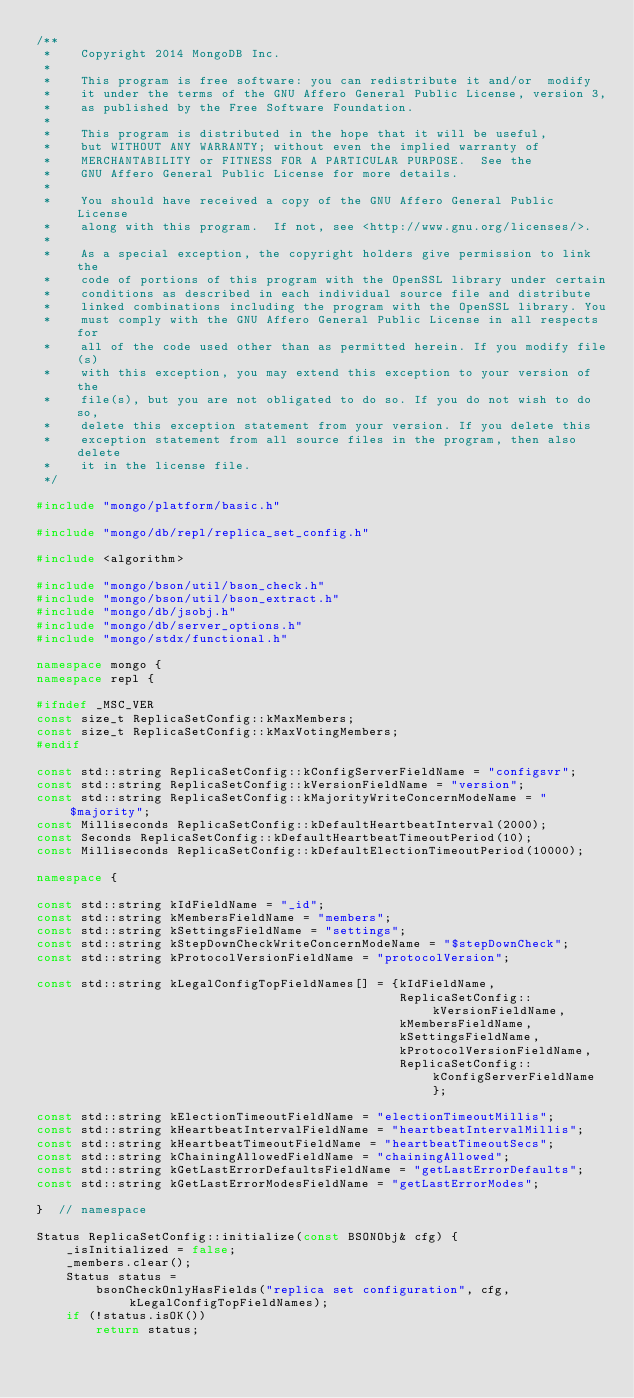<code> <loc_0><loc_0><loc_500><loc_500><_C++_>/**
 *    Copyright 2014 MongoDB Inc.
 *
 *    This program is free software: you can redistribute it and/or  modify
 *    it under the terms of the GNU Affero General Public License, version 3,
 *    as published by the Free Software Foundation.
 *
 *    This program is distributed in the hope that it will be useful,
 *    but WITHOUT ANY WARRANTY; without even the implied warranty of
 *    MERCHANTABILITY or FITNESS FOR A PARTICULAR PURPOSE.  See the
 *    GNU Affero General Public License for more details.
 *
 *    You should have received a copy of the GNU Affero General Public License
 *    along with this program.  If not, see <http://www.gnu.org/licenses/>.
 *
 *    As a special exception, the copyright holders give permission to link the
 *    code of portions of this program with the OpenSSL library under certain
 *    conditions as described in each individual source file and distribute
 *    linked combinations including the program with the OpenSSL library. You
 *    must comply with the GNU Affero General Public License in all respects for
 *    all of the code used other than as permitted herein. If you modify file(s)
 *    with this exception, you may extend this exception to your version of the
 *    file(s), but you are not obligated to do so. If you do not wish to do so,
 *    delete this exception statement from your version. If you delete this
 *    exception statement from all source files in the program, then also delete
 *    it in the license file.
 */

#include "mongo/platform/basic.h"

#include "mongo/db/repl/replica_set_config.h"

#include <algorithm>

#include "mongo/bson/util/bson_check.h"
#include "mongo/bson/util/bson_extract.h"
#include "mongo/db/jsobj.h"
#include "mongo/db/server_options.h"
#include "mongo/stdx/functional.h"

namespace mongo {
namespace repl {

#ifndef _MSC_VER
const size_t ReplicaSetConfig::kMaxMembers;
const size_t ReplicaSetConfig::kMaxVotingMembers;
#endif

const std::string ReplicaSetConfig::kConfigServerFieldName = "configsvr";
const std::string ReplicaSetConfig::kVersionFieldName = "version";
const std::string ReplicaSetConfig::kMajorityWriteConcernModeName = "$majority";
const Milliseconds ReplicaSetConfig::kDefaultHeartbeatInterval(2000);
const Seconds ReplicaSetConfig::kDefaultHeartbeatTimeoutPeriod(10);
const Milliseconds ReplicaSetConfig::kDefaultElectionTimeoutPeriod(10000);

namespace {

const std::string kIdFieldName = "_id";
const std::string kMembersFieldName = "members";
const std::string kSettingsFieldName = "settings";
const std::string kStepDownCheckWriteConcernModeName = "$stepDownCheck";
const std::string kProtocolVersionFieldName = "protocolVersion";

const std::string kLegalConfigTopFieldNames[] = {kIdFieldName,
                                                 ReplicaSetConfig::kVersionFieldName,
                                                 kMembersFieldName,
                                                 kSettingsFieldName,
                                                 kProtocolVersionFieldName,
                                                 ReplicaSetConfig::kConfigServerFieldName};

const std::string kElectionTimeoutFieldName = "electionTimeoutMillis";
const std::string kHeartbeatIntervalFieldName = "heartbeatIntervalMillis";
const std::string kHeartbeatTimeoutFieldName = "heartbeatTimeoutSecs";
const std::string kChainingAllowedFieldName = "chainingAllowed";
const std::string kGetLastErrorDefaultsFieldName = "getLastErrorDefaults";
const std::string kGetLastErrorModesFieldName = "getLastErrorModes";

}  // namespace

Status ReplicaSetConfig::initialize(const BSONObj& cfg) {
    _isInitialized = false;
    _members.clear();
    Status status =
        bsonCheckOnlyHasFields("replica set configuration", cfg, kLegalConfigTopFieldNames);
    if (!status.isOK())
        return status;
</code> 